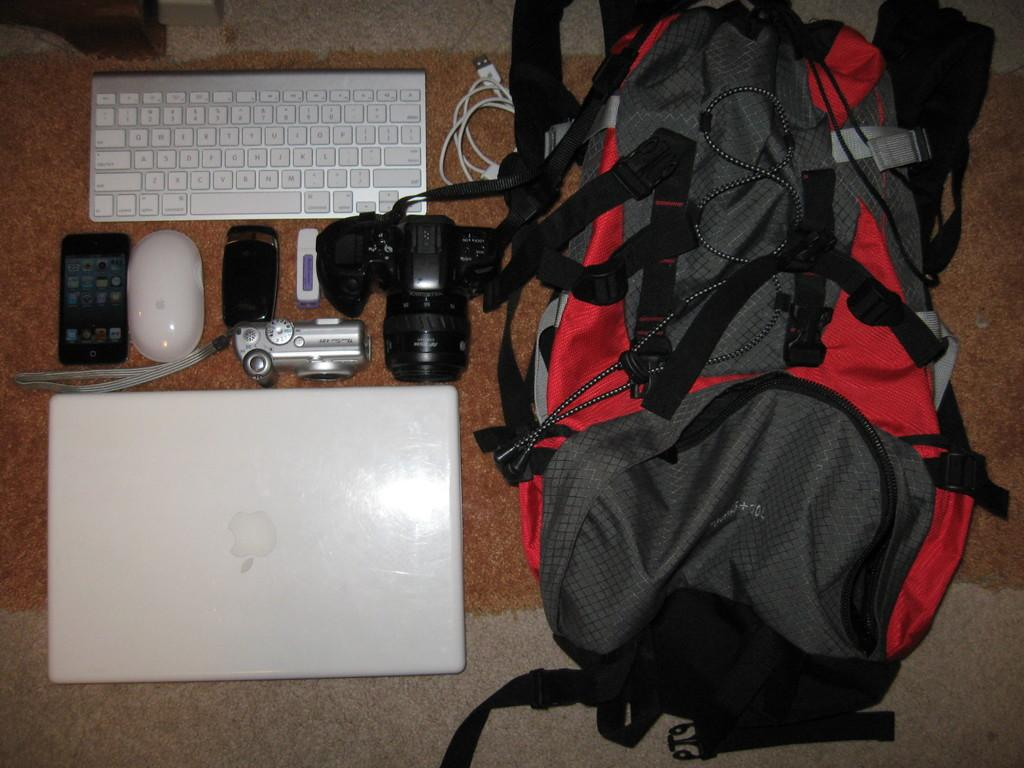What type of bag is visible in the image? The facts do not specify the type of bag. What electronic device is present in the image? There is a laptop in the image. What other electronic device is present in the image? There is a keyboard in the image. What additional electronic device is present in the image? There is a camera in the image. What other electronic device is present in the image? There is a cell phone in the image. What accessory is present in the image? There is a mouse in the image. Where are all these objects located in the image? All these objects are on the floor. How many family members are present in the image? There is no information about family members in the image; it only shows a bag, a laptop, a keyboard, a camera, a cell phone, and a mouse on the floor. What type of development is taking place in the image? There is no development taking place in the image; it only shows a bag, a laptop, a keyboard, a camera, a cell phone, and a mouse on the floor. 